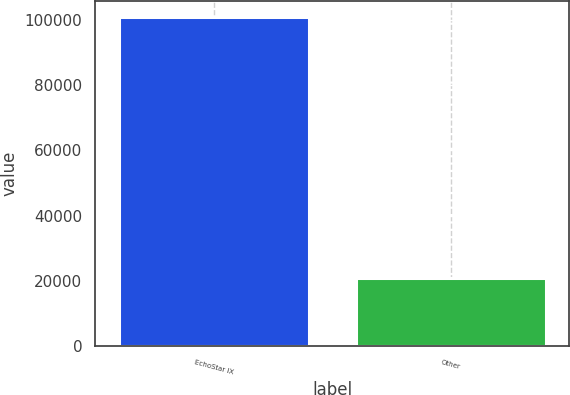<chart> <loc_0><loc_0><loc_500><loc_500><bar_chart><fcel>EchoStar IX<fcel>Other<nl><fcel>100745<fcel>20948<nl></chart> 